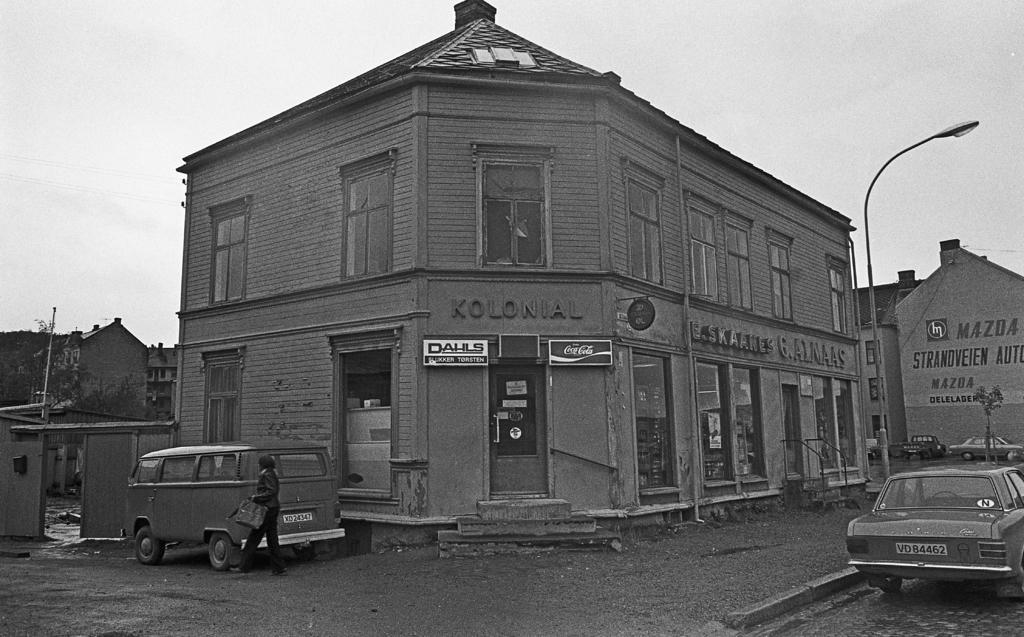What can be seen on the road in the image? There are vehicles on the road in the image. Are there any people on the road in the image? Yes, there is a person on the road in the image. What can be seen in the background of the image? There are buildings, poles, trees, and the sky visible in the background of the image. Can you describe the unspecified objects in the background of the image? Unfortunately, the provided facts do not specify the nature of these objects, so it is not possible to describe them. What type of island can be seen in the image? There is no island present in the image; it features a road with vehicles and a person, as well as a background with buildings, poles, trees, and the sky. How does the friction between the vehicles and the road affect the person walking on the road? The provided facts do not mention any friction between the vehicles and the road, nor do they specify any interaction between the person and the vehicles. 